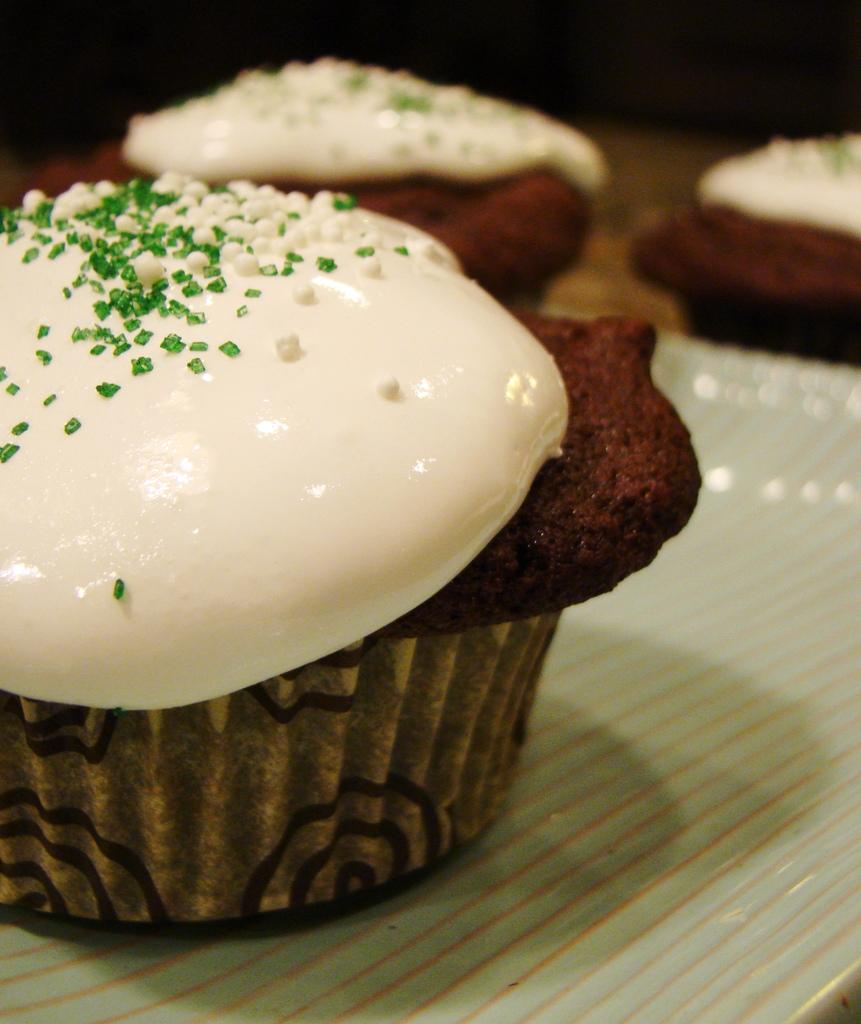What type of dessert can be seen on the tray in the image? There are cupcakes on a tray in the image. What can be observed about the lighting or color of the background in the image? The background of the image is dark. What type of sheet is covering the sand in the image? There is no sheet or sand present in the image; it only features cupcakes on a tray and a dark background. 